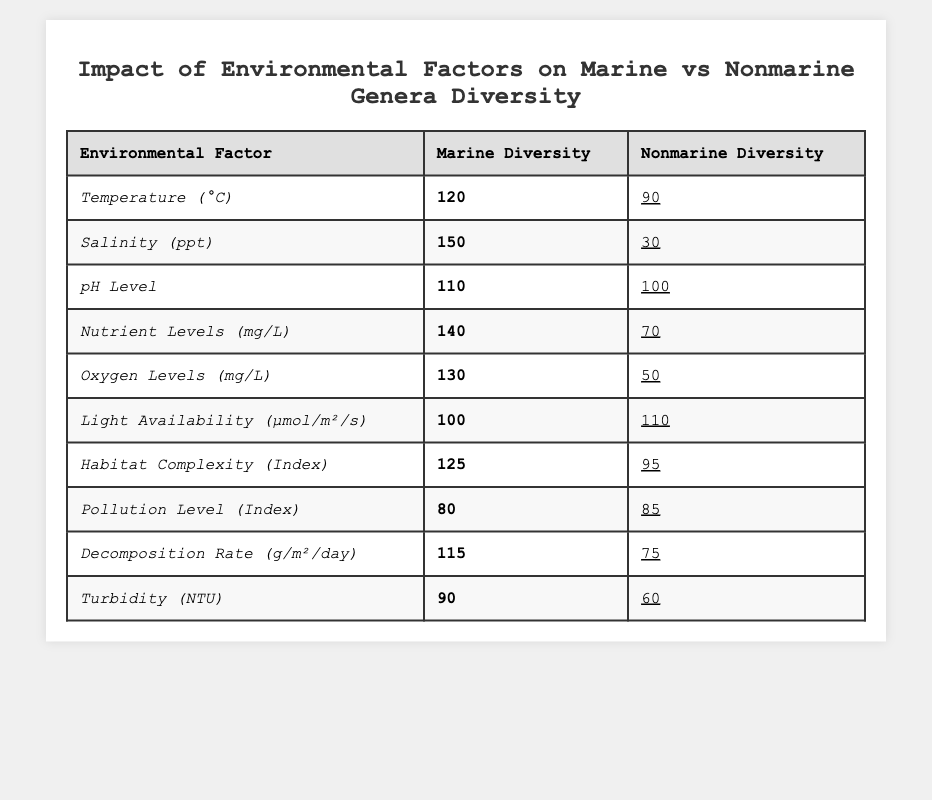What is the marine diversity value for salinity? The table lists the marine diversity for salinity as 150.
Answer: 150 What is the nonmarine diversity for temperature? The table shows the nonmarine diversity for temperature as 90.
Answer: 90 What environmental factor has the highest marine diversity? By comparing the values in the marine diversity column, salinity has the highest value of 150.
Answer: Salinity What is the difference in marine and nonmarine diversity for nutrient levels? Marine diversity for nutrient levels is 140 and nonmarine is 70. The difference is 140 - 70 = 70.
Answer: 70 What is the average nonmarine diversity across all environmental factors? The total nonmarine diversity values are 90 + 30 + 100 + 70 + 50 + 110 + 95 + 85 + 75 + 60 = 750. Dividing by the number of factors (10) gives an average of 750/10 = 75.
Answer: 75 Is the oxygen levels impact on marine diversity greater than that on nonmarine diversity? The marine diversity for oxygen levels is 130, and the nonmarine diversity is 50, showing that marine diversity is indeed greater.
Answer: Yes Which environmental factor has a greater impact on nonmarine diversity, light availability or pollution level? Light availability has a nonmarine diversity of 110, while pollution level has 85. Since 110 is greater than 85, light availability has a greater impact.
Answer: Light availability How does the marine diversity for temperature compare to that for pH level? Marine diversity for temperature is 120 and for pH level is 110. Therefore, marine diversity for temperature is greater by 10 (120 - 110).
Answer: Temperature is greater by 10 What is the total marine diversity for all environmental factors? Adding the marine diversity values gives 120 + 150 + 110 + 140 + 130 + 100 + 125 + 80 + 115 + 90 = 1250.
Answer: 1250 Is it true that nonmarine diversity is always higher than marine diversity for pollution levels? For pollution levels, the marine diversity is 80 and the nonmarine diversity is 85, indicating that nonmarine diversity is higher in this case, but this is not always true for all factors.
Answer: True 